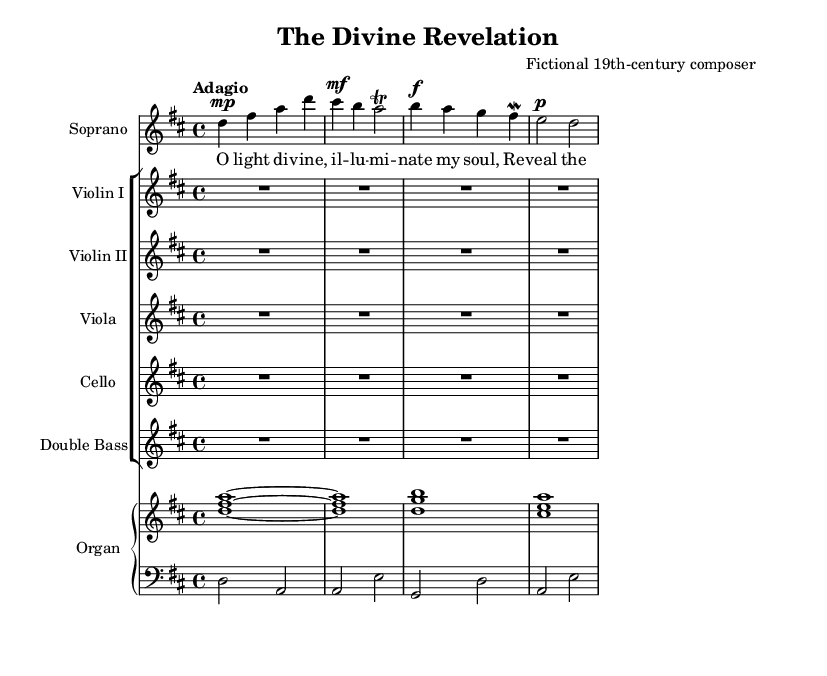What is the key signature of this music? The key signature is D major, which has two sharps. This can be determined by looking at the key signature symbol at the beginning of the staff.
Answer: D major What is the time signature of this piece? The time signature is 4/4, which can be found at the beginning of the music sheet next to the key signature. It indicates that there are four beats in each measure.
Answer: 4/4 What is the tempo marking of the piece? The tempo marking is "Adagio," which is indicated just above the staff. This tells us to play the piece slowly.
Answer: Adagio How many measures are in the soprano voice part? The soprano voice part has four measures, as indicated by the number of groups or sets of notes separated by vertical bar lines in the staff.
Answer: Four What instruments are included in the score? The score includes a Soprano, Violin I, Violin II, Viola, Cello, Double Bass, and Organ. This can be identified from the instrumental names at the beginning of each staff.
Answer: Soprano, Violin I, Violin II, Viola, Cello, Double Bass, Organ What type of musical form does this piece likely follow based on its structure? The piece likely follows a song form, typical in operas, as it has a clear melodic line in the soprano with accompaniment and is structured in a way that resembles a lyrical aria. This reasoning comes from the organization of voice and orchestration that is characteristic of operatic works.
Answer: Song form What voice dynamics are indicated in the soprano part? The dynamics indicated for the soprano part include "p" (piano, soft) and "f" (forte, loud), which are marked alongside the notes. This indicates changes in volume throughout the piece.
Answer: Piano, Forte 